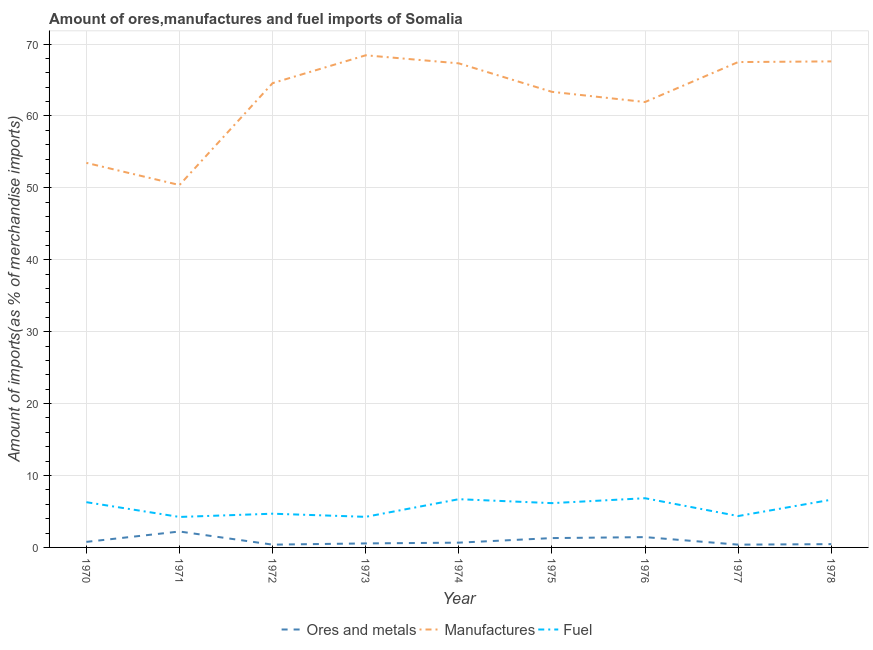How many different coloured lines are there?
Provide a short and direct response. 3. Does the line corresponding to percentage of fuel imports intersect with the line corresponding to percentage of manufactures imports?
Offer a very short reply. No. What is the percentage of fuel imports in 1977?
Provide a short and direct response. 4.36. Across all years, what is the maximum percentage of fuel imports?
Offer a terse response. 6.84. Across all years, what is the minimum percentage of ores and metals imports?
Offer a terse response. 0.39. In which year was the percentage of fuel imports maximum?
Offer a very short reply. 1976. In which year was the percentage of manufactures imports minimum?
Ensure brevity in your answer.  1971. What is the total percentage of ores and metals imports in the graph?
Your answer should be very brief. 8.17. What is the difference between the percentage of manufactures imports in 1971 and that in 1978?
Make the answer very short. -17.19. What is the difference between the percentage of fuel imports in 1971 and the percentage of ores and metals imports in 1977?
Offer a very short reply. 3.85. What is the average percentage of manufactures imports per year?
Offer a very short reply. 62.73. In the year 1978, what is the difference between the percentage of manufactures imports and percentage of ores and metals imports?
Give a very brief answer. 67.13. What is the ratio of the percentage of manufactures imports in 1974 to that in 1978?
Provide a short and direct response. 1. Is the difference between the percentage of ores and metals imports in 1971 and 1973 greater than the difference between the percentage of fuel imports in 1971 and 1973?
Provide a short and direct response. Yes. What is the difference between the highest and the second highest percentage of ores and metals imports?
Your answer should be very brief. 0.78. What is the difference between the highest and the lowest percentage of ores and metals imports?
Keep it short and to the point. 1.83. In how many years, is the percentage of fuel imports greater than the average percentage of fuel imports taken over all years?
Provide a short and direct response. 5. Does the percentage of fuel imports monotonically increase over the years?
Keep it short and to the point. No. Is the percentage of fuel imports strictly greater than the percentage of manufactures imports over the years?
Offer a terse response. No. Is the percentage of ores and metals imports strictly less than the percentage of manufactures imports over the years?
Your answer should be very brief. Yes. How many lines are there?
Ensure brevity in your answer.  3. Does the graph contain any zero values?
Your answer should be very brief. No. Does the graph contain grids?
Your answer should be very brief. Yes. How are the legend labels stacked?
Your answer should be compact. Horizontal. What is the title of the graph?
Offer a terse response. Amount of ores,manufactures and fuel imports of Somalia. What is the label or title of the X-axis?
Your answer should be very brief. Year. What is the label or title of the Y-axis?
Offer a terse response. Amount of imports(as % of merchandise imports). What is the Amount of imports(as % of merchandise imports) of Ores and metals in 1970?
Your answer should be compact. 0.77. What is the Amount of imports(as % of merchandise imports) in Manufactures in 1970?
Your answer should be very brief. 53.47. What is the Amount of imports(as % of merchandise imports) in Fuel in 1970?
Provide a succinct answer. 6.29. What is the Amount of imports(as % of merchandise imports) of Ores and metals in 1971?
Ensure brevity in your answer.  2.21. What is the Amount of imports(as % of merchandise imports) of Manufactures in 1971?
Provide a succinct answer. 50.39. What is the Amount of imports(as % of merchandise imports) of Fuel in 1971?
Provide a succinct answer. 4.24. What is the Amount of imports(as % of merchandise imports) of Ores and metals in 1972?
Give a very brief answer. 0.39. What is the Amount of imports(as % of merchandise imports) of Manufactures in 1972?
Your answer should be very brief. 64.56. What is the Amount of imports(as % of merchandise imports) in Fuel in 1972?
Give a very brief answer. 4.69. What is the Amount of imports(as % of merchandise imports) in Ores and metals in 1973?
Make the answer very short. 0.56. What is the Amount of imports(as % of merchandise imports) in Manufactures in 1973?
Offer a very short reply. 68.43. What is the Amount of imports(as % of merchandise imports) in Fuel in 1973?
Your answer should be very brief. 4.25. What is the Amount of imports(as % of merchandise imports) of Ores and metals in 1974?
Ensure brevity in your answer.  0.66. What is the Amount of imports(as % of merchandise imports) in Manufactures in 1974?
Provide a short and direct response. 67.31. What is the Amount of imports(as % of merchandise imports) of Fuel in 1974?
Your answer should be compact. 6.71. What is the Amount of imports(as % of merchandise imports) in Ores and metals in 1975?
Your response must be concise. 1.3. What is the Amount of imports(as % of merchandise imports) of Manufactures in 1975?
Make the answer very short. 63.35. What is the Amount of imports(as % of merchandise imports) of Fuel in 1975?
Provide a succinct answer. 6.16. What is the Amount of imports(as % of merchandise imports) in Ores and metals in 1976?
Provide a short and direct response. 1.43. What is the Amount of imports(as % of merchandise imports) of Manufactures in 1976?
Offer a terse response. 61.94. What is the Amount of imports(as % of merchandise imports) of Fuel in 1976?
Provide a succinct answer. 6.84. What is the Amount of imports(as % of merchandise imports) in Ores and metals in 1977?
Provide a succinct answer. 0.39. What is the Amount of imports(as % of merchandise imports) of Manufactures in 1977?
Provide a short and direct response. 67.49. What is the Amount of imports(as % of merchandise imports) in Fuel in 1977?
Offer a terse response. 4.36. What is the Amount of imports(as % of merchandise imports) of Ores and metals in 1978?
Offer a very short reply. 0.46. What is the Amount of imports(as % of merchandise imports) in Manufactures in 1978?
Provide a short and direct response. 67.59. What is the Amount of imports(as % of merchandise imports) of Fuel in 1978?
Your answer should be very brief. 6.63. Across all years, what is the maximum Amount of imports(as % of merchandise imports) in Ores and metals?
Your response must be concise. 2.21. Across all years, what is the maximum Amount of imports(as % of merchandise imports) of Manufactures?
Provide a succinct answer. 68.43. Across all years, what is the maximum Amount of imports(as % of merchandise imports) of Fuel?
Keep it short and to the point. 6.84. Across all years, what is the minimum Amount of imports(as % of merchandise imports) of Ores and metals?
Offer a very short reply. 0.39. Across all years, what is the minimum Amount of imports(as % of merchandise imports) of Manufactures?
Keep it short and to the point. 50.39. Across all years, what is the minimum Amount of imports(as % of merchandise imports) in Fuel?
Your answer should be compact. 4.24. What is the total Amount of imports(as % of merchandise imports) of Ores and metals in the graph?
Ensure brevity in your answer.  8.17. What is the total Amount of imports(as % of merchandise imports) of Manufactures in the graph?
Provide a succinct answer. 564.54. What is the total Amount of imports(as % of merchandise imports) in Fuel in the graph?
Make the answer very short. 50.18. What is the difference between the Amount of imports(as % of merchandise imports) of Ores and metals in 1970 and that in 1971?
Make the answer very short. -1.44. What is the difference between the Amount of imports(as % of merchandise imports) in Manufactures in 1970 and that in 1971?
Provide a succinct answer. 3.08. What is the difference between the Amount of imports(as % of merchandise imports) in Fuel in 1970 and that in 1971?
Offer a very short reply. 2.05. What is the difference between the Amount of imports(as % of merchandise imports) in Ores and metals in 1970 and that in 1972?
Ensure brevity in your answer.  0.39. What is the difference between the Amount of imports(as % of merchandise imports) in Manufactures in 1970 and that in 1972?
Your answer should be compact. -11.09. What is the difference between the Amount of imports(as % of merchandise imports) in Fuel in 1970 and that in 1972?
Your response must be concise. 1.6. What is the difference between the Amount of imports(as % of merchandise imports) in Ores and metals in 1970 and that in 1973?
Ensure brevity in your answer.  0.21. What is the difference between the Amount of imports(as % of merchandise imports) of Manufactures in 1970 and that in 1973?
Keep it short and to the point. -14.96. What is the difference between the Amount of imports(as % of merchandise imports) in Fuel in 1970 and that in 1973?
Your response must be concise. 2.04. What is the difference between the Amount of imports(as % of merchandise imports) of Ores and metals in 1970 and that in 1974?
Provide a short and direct response. 0.11. What is the difference between the Amount of imports(as % of merchandise imports) of Manufactures in 1970 and that in 1974?
Your response must be concise. -13.84. What is the difference between the Amount of imports(as % of merchandise imports) in Fuel in 1970 and that in 1974?
Make the answer very short. -0.42. What is the difference between the Amount of imports(as % of merchandise imports) in Ores and metals in 1970 and that in 1975?
Your response must be concise. -0.53. What is the difference between the Amount of imports(as % of merchandise imports) of Manufactures in 1970 and that in 1975?
Your answer should be compact. -9.88. What is the difference between the Amount of imports(as % of merchandise imports) in Fuel in 1970 and that in 1975?
Provide a succinct answer. 0.13. What is the difference between the Amount of imports(as % of merchandise imports) of Ores and metals in 1970 and that in 1976?
Your answer should be compact. -0.66. What is the difference between the Amount of imports(as % of merchandise imports) in Manufactures in 1970 and that in 1976?
Your answer should be very brief. -8.46. What is the difference between the Amount of imports(as % of merchandise imports) in Fuel in 1970 and that in 1976?
Your response must be concise. -0.55. What is the difference between the Amount of imports(as % of merchandise imports) of Ores and metals in 1970 and that in 1977?
Make the answer very short. 0.38. What is the difference between the Amount of imports(as % of merchandise imports) in Manufactures in 1970 and that in 1977?
Make the answer very short. -14.02. What is the difference between the Amount of imports(as % of merchandise imports) in Fuel in 1970 and that in 1977?
Give a very brief answer. 1.93. What is the difference between the Amount of imports(as % of merchandise imports) in Ores and metals in 1970 and that in 1978?
Your response must be concise. 0.31. What is the difference between the Amount of imports(as % of merchandise imports) in Manufactures in 1970 and that in 1978?
Your answer should be compact. -14.11. What is the difference between the Amount of imports(as % of merchandise imports) of Fuel in 1970 and that in 1978?
Provide a short and direct response. -0.34. What is the difference between the Amount of imports(as % of merchandise imports) of Ores and metals in 1971 and that in 1972?
Your answer should be very brief. 1.83. What is the difference between the Amount of imports(as % of merchandise imports) of Manufactures in 1971 and that in 1972?
Make the answer very short. -14.17. What is the difference between the Amount of imports(as % of merchandise imports) in Fuel in 1971 and that in 1972?
Keep it short and to the point. -0.45. What is the difference between the Amount of imports(as % of merchandise imports) of Ores and metals in 1971 and that in 1973?
Give a very brief answer. 1.66. What is the difference between the Amount of imports(as % of merchandise imports) in Manufactures in 1971 and that in 1973?
Make the answer very short. -18.04. What is the difference between the Amount of imports(as % of merchandise imports) of Fuel in 1971 and that in 1973?
Give a very brief answer. -0.02. What is the difference between the Amount of imports(as % of merchandise imports) in Ores and metals in 1971 and that in 1974?
Your response must be concise. 1.55. What is the difference between the Amount of imports(as % of merchandise imports) of Manufactures in 1971 and that in 1974?
Keep it short and to the point. -16.92. What is the difference between the Amount of imports(as % of merchandise imports) in Fuel in 1971 and that in 1974?
Make the answer very short. -2.47. What is the difference between the Amount of imports(as % of merchandise imports) of Ores and metals in 1971 and that in 1975?
Ensure brevity in your answer.  0.92. What is the difference between the Amount of imports(as % of merchandise imports) in Manufactures in 1971 and that in 1975?
Keep it short and to the point. -12.96. What is the difference between the Amount of imports(as % of merchandise imports) of Fuel in 1971 and that in 1975?
Make the answer very short. -1.92. What is the difference between the Amount of imports(as % of merchandise imports) in Ores and metals in 1971 and that in 1976?
Your answer should be very brief. 0.78. What is the difference between the Amount of imports(as % of merchandise imports) of Manufactures in 1971 and that in 1976?
Keep it short and to the point. -11.54. What is the difference between the Amount of imports(as % of merchandise imports) in Fuel in 1971 and that in 1976?
Provide a short and direct response. -2.6. What is the difference between the Amount of imports(as % of merchandise imports) of Ores and metals in 1971 and that in 1977?
Make the answer very short. 1.83. What is the difference between the Amount of imports(as % of merchandise imports) in Manufactures in 1971 and that in 1977?
Make the answer very short. -17.1. What is the difference between the Amount of imports(as % of merchandise imports) of Fuel in 1971 and that in 1977?
Give a very brief answer. -0.12. What is the difference between the Amount of imports(as % of merchandise imports) of Ores and metals in 1971 and that in 1978?
Your answer should be very brief. 1.76. What is the difference between the Amount of imports(as % of merchandise imports) in Manufactures in 1971 and that in 1978?
Offer a very short reply. -17.19. What is the difference between the Amount of imports(as % of merchandise imports) of Fuel in 1971 and that in 1978?
Give a very brief answer. -2.4. What is the difference between the Amount of imports(as % of merchandise imports) in Ores and metals in 1972 and that in 1973?
Make the answer very short. -0.17. What is the difference between the Amount of imports(as % of merchandise imports) of Manufactures in 1972 and that in 1973?
Your answer should be very brief. -3.87. What is the difference between the Amount of imports(as % of merchandise imports) in Fuel in 1972 and that in 1973?
Keep it short and to the point. 0.43. What is the difference between the Amount of imports(as % of merchandise imports) in Ores and metals in 1972 and that in 1974?
Offer a terse response. -0.28. What is the difference between the Amount of imports(as % of merchandise imports) in Manufactures in 1972 and that in 1974?
Provide a succinct answer. -2.75. What is the difference between the Amount of imports(as % of merchandise imports) in Fuel in 1972 and that in 1974?
Your answer should be very brief. -2.02. What is the difference between the Amount of imports(as % of merchandise imports) in Ores and metals in 1972 and that in 1975?
Ensure brevity in your answer.  -0.91. What is the difference between the Amount of imports(as % of merchandise imports) of Manufactures in 1972 and that in 1975?
Provide a short and direct response. 1.21. What is the difference between the Amount of imports(as % of merchandise imports) in Fuel in 1972 and that in 1975?
Your answer should be compact. -1.47. What is the difference between the Amount of imports(as % of merchandise imports) in Ores and metals in 1972 and that in 1976?
Offer a terse response. -1.05. What is the difference between the Amount of imports(as % of merchandise imports) of Manufactures in 1972 and that in 1976?
Provide a short and direct response. 2.63. What is the difference between the Amount of imports(as % of merchandise imports) of Fuel in 1972 and that in 1976?
Provide a succinct answer. -2.15. What is the difference between the Amount of imports(as % of merchandise imports) of Ores and metals in 1972 and that in 1977?
Offer a very short reply. -0. What is the difference between the Amount of imports(as % of merchandise imports) in Manufactures in 1972 and that in 1977?
Give a very brief answer. -2.93. What is the difference between the Amount of imports(as % of merchandise imports) of Fuel in 1972 and that in 1977?
Make the answer very short. 0.33. What is the difference between the Amount of imports(as % of merchandise imports) in Ores and metals in 1972 and that in 1978?
Ensure brevity in your answer.  -0.07. What is the difference between the Amount of imports(as % of merchandise imports) in Manufactures in 1972 and that in 1978?
Your answer should be compact. -3.02. What is the difference between the Amount of imports(as % of merchandise imports) in Fuel in 1972 and that in 1978?
Offer a terse response. -1.95. What is the difference between the Amount of imports(as % of merchandise imports) of Ores and metals in 1973 and that in 1974?
Give a very brief answer. -0.11. What is the difference between the Amount of imports(as % of merchandise imports) of Manufactures in 1973 and that in 1974?
Provide a succinct answer. 1.12. What is the difference between the Amount of imports(as % of merchandise imports) of Fuel in 1973 and that in 1974?
Ensure brevity in your answer.  -2.45. What is the difference between the Amount of imports(as % of merchandise imports) in Ores and metals in 1973 and that in 1975?
Provide a short and direct response. -0.74. What is the difference between the Amount of imports(as % of merchandise imports) in Manufactures in 1973 and that in 1975?
Offer a very short reply. 5.08. What is the difference between the Amount of imports(as % of merchandise imports) in Fuel in 1973 and that in 1975?
Offer a very short reply. -1.9. What is the difference between the Amount of imports(as % of merchandise imports) of Ores and metals in 1973 and that in 1976?
Ensure brevity in your answer.  -0.88. What is the difference between the Amount of imports(as % of merchandise imports) in Manufactures in 1973 and that in 1976?
Provide a short and direct response. 6.5. What is the difference between the Amount of imports(as % of merchandise imports) in Fuel in 1973 and that in 1976?
Give a very brief answer. -2.59. What is the difference between the Amount of imports(as % of merchandise imports) of Ores and metals in 1973 and that in 1977?
Offer a terse response. 0.17. What is the difference between the Amount of imports(as % of merchandise imports) of Manufactures in 1973 and that in 1977?
Offer a terse response. 0.94. What is the difference between the Amount of imports(as % of merchandise imports) of Fuel in 1973 and that in 1977?
Your response must be concise. -0.11. What is the difference between the Amount of imports(as % of merchandise imports) in Ores and metals in 1973 and that in 1978?
Make the answer very short. 0.1. What is the difference between the Amount of imports(as % of merchandise imports) in Manufactures in 1973 and that in 1978?
Keep it short and to the point. 0.85. What is the difference between the Amount of imports(as % of merchandise imports) in Fuel in 1973 and that in 1978?
Keep it short and to the point. -2.38. What is the difference between the Amount of imports(as % of merchandise imports) in Ores and metals in 1974 and that in 1975?
Your answer should be very brief. -0.64. What is the difference between the Amount of imports(as % of merchandise imports) of Manufactures in 1974 and that in 1975?
Provide a succinct answer. 3.96. What is the difference between the Amount of imports(as % of merchandise imports) of Fuel in 1974 and that in 1975?
Provide a succinct answer. 0.55. What is the difference between the Amount of imports(as % of merchandise imports) in Ores and metals in 1974 and that in 1976?
Make the answer very short. -0.77. What is the difference between the Amount of imports(as % of merchandise imports) in Manufactures in 1974 and that in 1976?
Offer a very short reply. 5.38. What is the difference between the Amount of imports(as % of merchandise imports) in Fuel in 1974 and that in 1976?
Ensure brevity in your answer.  -0.13. What is the difference between the Amount of imports(as % of merchandise imports) of Ores and metals in 1974 and that in 1977?
Keep it short and to the point. 0.28. What is the difference between the Amount of imports(as % of merchandise imports) of Manufactures in 1974 and that in 1977?
Give a very brief answer. -0.18. What is the difference between the Amount of imports(as % of merchandise imports) in Fuel in 1974 and that in 1977?
Provide a succinct answer. 2.35. What is the difference between the Amount of imports(as % of merchandise imports) of Ores and metals in 1974 and that in 1978?
Your answer should be compact. 0.21. What is the difference between the Amount of imports(as % of merchandise imports) of Manufactures in 1974 and that in 1978?
Ensure brevity in your answer.  -0.27. What is the difference between the Amount of imports(as % of merchandise imports) of Fuel in 1974 and that in 1978?
Make the answer very short. 0.07. What is the difference between the Amount of imports(as % of merchandise imports) in Ores and metals in 1975 and that in 1976?
Your response must be concise. -0.14. What is the difference between the Amount of imports(as % of merchandise imports) of Manufactures in 1975 and that in 1976?
Make the answer very short. 1.42. What is the difference between the Amount of imports(as % of merchandise imports) of Fuel in 1975 and that in 1976?
Your answer should be compact. -0.68. What is the difference between the Amount of imports(as % of merchandise imports) in Ores and metals in 1975 and that in 1977?
Provide a succinct answer. 0.91. What is the difference between the Amount of imports(as % of merchandise imports) in Manufactures in 1975 and that in 1977?
Make the answer very short. -4.14. What is the difference between the Amount of imports(as % of merchandise imports) in Fuel in 1975 and that in 1977?
Keep it short and to the point. 1.8. What is the difference between the Amount of imports(as % of merchandise imports) in Ores and metals in 1975 and that in 1978?
Offer a very short reply. 0.84. What is the difference between the Amount of imports(as % of merchandise imports) of Manufactures in 1975 and that in 1978?
Provide a short and direct response. -4.23. What is the difference between the Amount of imports(as % of merchandise imports) in Fuel in 1975 and that in 1978?
Give a very brief answer. -0.48. What is the difference between the Amount of imports(as % of merchandise imports) of Ores and metals in 1976 and that in 1977?
Offer a very short reply. 1.05. What is the difference between the Amount of imports(as % of merchandise imports) of Manufactures in 1976 and that in 1977?
Give a very brief answer. -5.56. What is the difference between the Amount of imports(as % of merchandise imports) of Fuel in 1976 and that in 1977?
Your answer should be compact. 2.48. What is the difference between the Amount of imports(as % of merchandise imports) of Ores and metals in 1976 and that in 1978?
Your answer should be compact. 0.98. What is the difference between the Amount of imports(as % of merchandise imports) of Manufactures in 1976 and that in 1978?
Provide a succinct answer. -5.65. What is the difference between the Amount of imports(as % of merchandise imports) of Fuel in 1976 and that in 1978?
Provide a succinct answer. 0.21. What is the difference between the Amount of imports(as % of merchandise imports) of Ores and metals in 1977 and that in 1978?
Offer a terse response. -0.07. What is the difference between the Amount of imports(as % of merchandise imports) of Manufactures in 1977 and that in 1978?
Give a very brief answer. -0.09. What is the difference between the Amount of imports(as % of merchandise imports) in Fuel in 1977 and that in 1978?
Provide a short and direct response. -2.27. What is the difference between the Amount of imports(as % of merchandise imports) in Ores and metals in 1970 and the Amount of imports(as % of merchandise imports) in Manufactures in 1971?
Provide a short and direct response. -49.62. What is the difference between the Amount of imports(as % of merchandise imports) in Ores and metals in 1970 and the Amount of imports(as % of merchandise imports) in Fuel in 1971?
Provide a succinct answer. -3.47. What is the difference between the Amount of imports(as % of merchandise imports) of Manufactures in 1970 and the Amount of imports(as % of merchandise imports) of Fuel in 1971?
Provide a succinct answer. 49.24. What is the difference between the Amount of imports(as % of merchandise imports) of Ores and metals in 1970 and the Amount of imports(as % of merchandise imports) of Manufactures in 1972?
Ensure brevity in your answer.  -63.79. What is the difference between the Amount of imports(as % of merchandise imports) of Ores and metals in 1970 and the Amount of imports(as % of merchandise imports) of Fuel in 1972?
Provide a succinct answer. -3.92. What is the difference between the Amount of imports(as % of merchandise imports) of Manufactures in 1970 and the Amount of imports(as % of merchandise imports) of Fuel in 1972?
Give a very brief answer. 48.79. What is the difference between the Amount of imports(as % of merchandise imports) in Ores and metals in 1970 and the Amount of imports(as % of merchandise imports) in Manufactures in 1973?
Offer a very short reply. -67.66. What is the difference between the Amount of imports(as % of merchandise imports) in Ores and metals in 1970 and the Amount of imports(as % of merchandise imports) in Fuel in 1973?
Your response must be concise. -3.48. What is the difference between the Amount of imports(as % of merchandise imports) in Manufactures in 1970 and the Amount of imports(as % of merchandise imports) in Fuel in 1973?
Provide a succinct answer. 49.22. What is the difference between the Amount of imports(as % of merchandise imports) of Ores and metals in 1970 and the Amount of imports(as % of merchandise imports) of Manufactures in 1974?
Your answer should be very brief. -66.54. What is the difference between the Amount of imports(as % of merchandise imports) in Ores and metals in 1970 and the Amount of imports(as % of merchandise imports) in Fuel in 1974?
Provide a short and direct response. -5.94. What is the difference between the Amount of imports(as % of merchandise imports) of Manufactures in 1970 and the Amount of imports(as % of merchandise imports) of Fuel in 1974?
Offer a very short reply. 46.77. What is the difference between the Amount of imports(as % of merchandise imports) of Ores and metals in 1970 and the Amount of imports(as % of merchandise imports) of Manufactures in 1975?
Keep it short and to the point. -62.58. What is the difference between the Amount of imports(as % of merchandise imports) of Ores and metals in 1970 and the Amount of imports(as % of merchandise imports) of Fuel in 1975?
Offer a terse response. -5.39. What is the difference between the Amount of imports(as % of merchandise imports) in Manufactures in 1970 and the Amount of imports(as % of merchandise imports) in Fuel in 1975?
Your response must be concise. 47.32. What is the difference between the Amount of imports(as % of merchandise imports) in Ores and metals in 1970 and the Amount of imports(as % of merchandise imports) in Manufactures in 1976?
Give a very brief answer. -61.16. What is the difference between the Amount of imports(as % of merchandise imports) in Ores and metals in 1970 and the Amount of imports(as % of merchandise imports) in Fuel in 1976?
Your answer should be compact. -6.07. What is the difference between the Amount of imports(as % of merchandise imports) in Manufactures in 1970 and the Amount of imports(as % of merchandise imports) in Fuel in 1976?
Your answer should be compact. 46.63. What is the difference between the Amount of imports(as % of merchandise imports) in Ores and metals in 1970 and the Amount of imports(as % of merchandise imports) in Manufactures in 1977?
Offer a very short reply. -66.72. What is the difference between the Amount of imports(as % of merchandise imports) in Ores and metals in 1970 and the Amount of imports(as % of merchandise imports) in Fuel in 1977?
Offer a very short reply. -3.59. What is the difference between the Amount of imports(as % of merchandise imports) of Manufactures in 1970 and the Amount of imports(as % of merchandise imports) of Fuel in 1977?
Provide a short and direct response. 49.11. What is the difference between the Amount of imports(as % of merchandise imports) in Ores and metals in 1970 and the Amount of imports(as % of merchandise imports) in Manufactures in 1978?
Provide a succinct answer. -66.81. What is the difference between the Amount of imports(as % of merchandise imports) in Ores and metals in 1970 and the Amount of imports(as % of merchandise imports) in Fuel in 1978?
Ensure brevity in your answer.  -5.86. What is the difference between the Amount of imports(as % of merchandise imports) in Manufactures in 1970 and the Amount of imports(as % of merchandise imports) in Fuel in 1978?
Make the answer very short. 46.84. What is the difference between the Amount of imports(as % of merchandise imports) of Ores and metals in 1971 and the Amount of imports(as % of merchandise imports) of Manufactures in 1972?
Your answer should be very brief. -62.35. What is the difference between the Amount of imports(as % of merchandise imports) of Ores and metals in 1971 and the Amount of imports(as % of merchandise imports) of Fuel in 1972?
Provide a short and direct response. -2.48. What is the difference between the Amount of imports(as % of merchandise imports) in Manufactures in 1971 and the Amount of imports(as % of merchandise imports) in Fuel in 1972?
Your response must be concise. 45.7. What is the difference between the Amount of imports(as % of merchandise imports) in Ores and metals in 1971 and the Amount of imports(as % of merchandise imports) in Manufactures in 1973?
Keep it short and to the point. -66.22. What is the difference between the Amount of imports(as % of merchandise imports) in Ores and metals in 1971 and the Amount of imports(as % of merchandise imports) in Fuel in 1973?
Your response must be concise. -2.04. What is the difference between the Amount of imports(as % of merchandise imports) of Manufactures in 1971 and the Amount of imports(as % of merchandise imports) of Fuel in 1973?
Your answer should be compact. 46.14. What is the difference between the Amount of imports(as % of merchandise imports) of Ores and metals in 1971 and the Amount of imports(as % of merchandise imports) of Manufactures in 1974?
Provide a short and direct response. -65.1. What is the difference between the Amount of imports(as % of merchandise imports) in Ores and metals in 1971 and the Amount of imports(as % of merchandise imports) in Fuel in 1974?
Make the answer very short. -4.49. What is the difference between the Amount of imports(as % of merchandise imports) of Manufactures in 1971 and the Amount of imports(as % of merchandise imports) of Fuel in 1974?
Your response must be concise. 43.68. What is the difference between the Amount of imports(as % of merchandise imports) of Ores and metals in 1971 and the Amount of imports(as % of merchandise imports) of Manufactures in 1975?
Provide a succinct answer. -61.14. What is the difference between the Amount of imports(as % of merchandise imports) of Ores and metals in 1971 and the Amount of imports(as % of merchandise imports) of Fuel in 1975?
Your answer should be very brief. -3.94. What is the difference between the Amount of imports(as % of merchandise imports) of Manufactures in 1971 and the Amount of imports(as % of merchandise imports) of Fuel in 1975?
Keep it short and to the point. 44.23. What is the difference between the Amount of imports(as % of merchandise imports) of Ores and metals in 1971 and the Amount of imports(as % of merchandise imports) of Manufactures in 1976?
Provide a short and direct response. -59.72. What is the difference between the Amount of imports(as % of merchandise imports) of Ores and metals in 1971 and the Amount of imports(as % of merchandise imports) of Fuel in 1976?
Your response must be concise. -4.63. What is the difference between the Amount of imports(as % of merchandise imports) in Manufactures in 1971 and the Amount of imports(as % of merchandise imports) in Fuel in 1976?
Provide a succinct answer. 43.55. What is the difference between the Amount of imports(as % of merchandise imports) in Ores and metals in 1971 and the Amount of imports(as % of merchandise imports) in Manufactures in 1977?
Provide a short and direct response. -65.28. What is the difference between the Amount of imports(as % of merchandise imports) in Ores and metals in 1971 and the Amount of imports(as % of merchandise imports) in Fuel in 1977?
Provide a short and direct response. -2.15. What is the difference between the Amount of imports(as % of merchandise imports) of Manufactures in 1971 and the Amount of imports(as % of merchandise imports) of Fuel in 1977?
Your answer should be very brief. 46.03. What is the difference between the Amount of imports(as % of merchandise imports) of Ores and metals in 1971 and the Amount of imports(as % of merchandise imports) of Manufactures in 1978?
Your answer should be compact. -65.37. What is the difference between the Amount of imports(as % of merchandise imports) of Ores and metals in 1971 and the Amount of imports(as % of merchandise imports) of Fuel in 1978?
Make the answer very short. -4.42. What is the difference between the Amount of imports(as % of merchandise imports) in Manufactures in 1971 and the Amount of imports(as % of merchandise imports) in Fuel in 1978?
Provide a short and direct response. 43.76. What is the difference between the Amount of imports(as % of merchandise imports) in Ores and metals in 1972 and the Amount of imports(as % of merchandise imports) in Manufactures in 1973?
Ensure brevity in your answer.  -68.05. What is the difference between the Amount of imports(as % of merchandise imports) in Ores and metals in 1972 and the Amount of imports(as % of merchandise imports) in Fuel in 1973?
Give a very brief answer. -3.87. What is the difference between the Amount of imports(as % of merchandise imports) in Manufactures in 1972 and the Amount of imports(as % of merchandise imports) in Fuel in 1973?
Your response must be concise. 60.31. What is the difference between the Amount of imports(as % of merchandise imports) in Ores and metals in 1972 and the Amount of imports(as % of merchandise imports) in Manufactures in 1974?
Provide a short and direct response. -66.93. What is the difference between the Amount of imports(as % of merchandise imports) of Ores and metals in 1972 and the Amount of imports(as % of merchandise imports) of Fuel in 1974?
Provide a short and direct response. -6.32. What is the difference between the Amount of imports(as % of merchandise imports) in Manufactures in 1972 and the Amount of imports(as % of merchandise imports) in Fuel in 1974?
Make the answer very short. 57.85. What is the difference between the Amount of imports(as % of merchandise imports) in Ores and metals in 1972 and the Amount of imports(as % of merchandise imports) in Manufactures in 1975?
Provide a succinct answer. -62.97. What is the difference between the Amount of imports(as % of merchandise imports) in Ores and metals in 1972 and the Amount of imports(as % of merchandise imports) in Fuel in 1975?
Your answer should be compact. -5.77. What is the difference between the Amount of imports(as % of merchandise imports) of Manufactures in 1972 and the Amount of imports(as % of merchandise imports) of Fuel in 1975?
Your response must be concise. 58.4. What is the difference between the Amount of imports(as % of merchandise imports) of Ores and metals in 1972 and the Amount of imports(as % of merchandise imports) of Manufactures in 1976?
Your answer should be very brief. -61.55. What is the difference between the Amount of imports(as % of merchandise imports) in Ores and metals in 1972 and the Amount of imports(as % of merchandise imports) in Fuel in 1976?
Keep it short and to the point. -6.45. What is the difference between the Amount of imports(as % of merchandise imports) of Manufactures in 1972 and the Amount of imports(as % of merchandise imports) of Fuel in 1976?
Provide a short and direct response. 57.72. What is the difference between the Amount of imports(as % of merchandise imports) in Ores and metals in 1972 and the Amount of imports(as % of merchandise imports) in Manufactures in 1977?
Give a very brief answer. -67.11. What is the difference between the Amount of imports(as % of merchandise imports) of Ores and metals in 1972 and the Amount of imports(as % of merchandise imports) of Fuel in 1977?
Keep it short and to the point. -3.98. What is the difference between the Amount of imports(as % of merchandise imports) in Manufactures in 1972 and the Amount of imports(as % of merchandise imports) in Fuel in 1977?
Make the answer very short. 60.2. What is the difference between the Amount of imports(as % of merchandise imports) of Ores and metals in 1972 and the Amount of imports(as % of merchandise imports) of Manufactures in 1978?
Your answer should be compact. -67.2. What is the difference between the Amount of imports(as % of merchandise imports) in Ores and metals in 1972 and the Amount of imports(as % of merchandise imports) in Fuel in 1978?
Offer a terse response. -6.25. What is the difference between the Amount of imports(as % of merchandise imports) in Manufactures in 1972 and the Amount of imports(as % of merchandise imports) in Fuel in 1978?
Ensure brevity in your answer.  57.93. What is the difference between the Amount of imports(as % of merchandise imports) of Ores and metals in 1973 and the Amount of imports(as % of merchandise imports) of Manufactures in 1974?
Ensure brevity in your answer.  -66.75. What is the difference between the Amount of imports(as % of merchandise imports) of Ores and metals in 1973 and the Amount of imports(as % of merchandise imports) of Fuel in 1974?
Give a very brief answer. -6.15. What is the difference between the Amount of imports(as % of merchandise imports) of Manufactures in 1973 and the Amount of imports(as % of merchandise imports) of Fuel in 1974?
Your response must be concise. 61.73. What is the difference between the Amount of imports(as % of merchandise imports) of Ores and metals in 1973 and the Amount of imports(as % of merchandise imports) of Manufactures in 1975?
Offer a very short reply. -62.79. What is the difference between the Amount of imports(as % of merchandise imports) of Ores and metals in 1973 and the Amount of imports(as % of merchandise imports) of Fuel in 1975?
Your response must be concise. -5.6. What is the difference between the Amount of imports(as % of merchandise imports) of Manufactures in 1973 and the Amount of imports(as % of merchandise imports) of Fuel in 1975?
Give a very brief answer. 62.28. What is the difference between the Amount of imports(as % of merchandise imports) of Ores and metals in 1973 and the Amount of imports(as % of merchandise imports) of Manufactures in 1976?
Your answer should be very brief. -61.38. What is the difference between the Amount of imports(as % of merchandise imports) in Ores and metals in 1973 and the Amount of imports(as % of merchandise imports) in Fuel in 1976?
Provide a short and direct response. -6.28. What is the difference between the Amount of imports(as % of merchandise imports) in Manufactures in 1973 and the Amount of imports(as % of merchandise imports) in Fuel in 1976?
Ensure brevity in your answer.  61.59. What is the difference between the Amount of imports(as % of merchandise imports) in Ores and metals in 1973 and the Amount of imports(as % of merchandise imports) in Manufactures in 1977?
Make the answer very short. -66.93. What is the difference between the Amount of imports(as % of merchandise imports) of Ores and metals in 1973 and the Amount of imports(as % of merchandise imports) of Fuel in 1977?
Offer a terse response. -3.8. What is the difference between the Amount of imports(as % of merchandise imports) of Manufactures in 1973 and the Amount of imports(as % of merchandise imports) of Fuel in 1977?
Give a very brief answer. 64.07. What is the difference between the Amount of imports(as % of merchandise imports) in Ores and metals in 1973 and the Amount of imports(as % of merchandise imports) in Manufactures in 1978?
Ensure brevity in your answer.  -67.03. What is the difference between the Amount of imports(as % of merchandise imports) of Ores and metals in 1973 and the Amount of imports(as % of merchandise imports) of Fuel in 1978?
Give a very brief answer. -6.08. What is the difference between the Amount of imports(as % of merchandise imports) in Manufactures in 1973 and the Amount of imports(as % of merchandise imports) in Fuel in 1978?
Provide a succinct answer. 61.8. What is the difference between the Amount of imports(as % of merchandise imports) of Ores and metals in 1974 and the Amount of imports(as % of merchandise imports) of Manufactures in 1975?
Offer a very short reply. -62.69. What is the difference between the Amount of imports(as % of merchandise imports) in Ores and metals in 1974 and the Amount of imports(as % of merchandise imports) in Fuel in 1975?
Your response must be concise. -5.5. What is the difference between the Amount of imports(as % of merchandise imports) of Manufactures in 1974 and the Amount of imports(as % of merchandise imports) of Fuel in 1975?
Your answer should be very brief. 61.15. What is the difference between the Amount of imports(as % of merchandise imports) in Ores and metals in 1974 and the Amount of imports(as % of merchandise imports) in Manufactures in 1976?
Offer a terse response. -61.27. What is the difference between the Amount of imports(as % of merchandise imports) of Ores and metals in 1974 and the Amount of imports(as % of merchandise imports) of Fuel in 1976?
Ensure brevity in your answer.  -6.18. What is the difference between the Amount of imports(as % of merchandise imports) in Manufactures in 1974 and the Amount of imports(as % of merchandise imports) in Fuel in 1976?
Ensure brevity in your answer.  60.47. What is the difference between the Amount of imports(as % of merchandise imports) in Ores and metals in 1974 and the Amount of imports(as % of merchandise imports) in Manufactures in 1977?
Provide a short and direct response. -66.83. What is the difference between the Amount of imports(as % of merchandise imports) of Ores and metals in 1974 and the Amount of imports(as % of merchandise imports) of Fuel in 1977?
Offer a very short reply. -3.7. What is the difference between the Amount of imports(as % of merchandise imports) of Manufactures in 1974 and the Amount of imports(as % of merchandise imports) of Fuel in 1977?
Ensure brevity in your answer.  62.95. What is the difference between the Amount of imports(as % of merchandise imports) of Ores and metals in 1974 and the Amount of imports(as % of merchandise imports) of Manufactures in 1978?
Your response must be concise. -66.92. What is the difference between the Amount of imports(as % of merchandise imports) in Ores and metals in 1974 and the Amount of imports(as % of merchandise imports) in Fuel in 1978?
Provide a succinct answer. -5.97. What is the difference between the Amount of imports(as % of merchandise imports) of Manufactures in 1974 and the Amount of imports(as % of merchandise imports) of Fuel in 1978?
Your response must be concise. 60.68. What is the difference between the Amount of imports(as % of merchandise imports) in Ores and metals in 1975 and the Amount of imports(as % of merchandise imports) in Manufactures in 1976?
Offer a very short reply. -60.64. What is the difference between the Amount of imports(as % of merchandise imports) in Ores and metals in 1975 and the Amount of imports(as % of merchandise imports) in Fuel in 1976?
Keep it short and to the point. -5.54. What is the difference between the Amount of imports(as % of merchandise imports) of Manufactures in 1975 and the Amount of imports(as % of merchandise imports) of Fuel in 1976?
Your response must be concise. 56.51. What is the difference between the Amount of imports(as % of merchandise imports) of Ores and metals in 1975 and the Amount of imports(as % of merchandise imports) of Manufactures in 1977?
Give a very brief answer. -66.19. What is the difference between the Amount of imports(as % of merchandise imports) of Ores and metals in 1975 and the Amount of imports(as % of merchandise imports) of Fuel in 1977?
Offer a terse response. -3.06. What is the difference between the Amount of imports(as % of merchandise imports) of Manufactures in 1975 and the Amount of imports(as % of merchandise imports) of Fuel in 1977?
Offer a terse response. 58.99. What is the difference between the Amount of imports(as % of merchandise imports) of Ores and metals in 1975 and the Amount of imports(as % of merchandise imports) of Manufactures in 1978?
Make the answer very short. -66.29. What is the difference between the Amount of imports(as % of merchandise imports) in Ores and metals in 1975 and the Amount of imports(as % of merchandise imports) in Fuel in 1978?
Give a very brief answer. -5.34. What is the difference between the Amount of imports(as % of merchandise imports) in Manufactures in 1975 and the Amount of imports(as % of merchandise imports) in Fuel in 1978?
Offer a terse response. 56.72. What is the difference between the Amount of imports(as % of merchandise imports) of Ores and metals in 1976 and the Amount of imports(as % of merchandise imports) of Manufactures in 1977?
Offer a terse response. -66.06. What is the difference between the Amount of imports(as % of merchandise imports) in Ores and metals in 1976 and the Amount of imports(as % of merchandise imports) in Fuel in 1977?
Provide a short and direct response. -2.93. What is the difference between the Amount of imports(as % of merchandise imports) in Manufactures in 1976 and the Amount of imports(as % of merchandise imports) in Fuel in 1977?
Make the answer very short. 57.57. What is the difference between the Amount of imports(as % of merchandise imports) in Ores and metals in 1976 and the Amount of imports(as % of merchandise imports) in Manufactures in 1978?
Make the answer very short. -66.15. What is the difference between the Amount of imports(as % of merchandise imports) in Ores and metals in 1976 and the Amount of imports(as % of merchandise imports) in Fuel in 1978?
Provide a succinct answer. -5.2. What is the difference between the Amount of imports(as % of merchandise imports) in Manufactures in 1976 and the Amount of imports(as % of merchandise imports) in Fuel in 1978?
Offer a terse response. 55.3. What is the difference between the Amount of imports(as % of merchandise imports) in Ores and metals in 1977 and the Amount of imports(as % of merchandise imports) in Manufactures in 1978?
Offer a very short reply. -67.2. What is the difference between the Amount of imports(as % of merchandise imports) in Ores and metals in 1977 and the Amount of imports(as % of merchandise imports) in Fuel in 1978?
Provide a short and direct response. -6.25. What is the difference between the Amount of imports(as % of merchandise imports) in Manufactures in 1977 and the Amount of imports(as % of merchandise imports) in Fuel in 1978?
Ensure brevity in your answer.  60.86. What is the average Amount of imports(as % of merchandise imports) of Ores and metals per year?
Give a very brief answer. 0.91. What is the average Amount of imports(as % of merchandise imports) of Manufactures per year?
Your answer should be very brief. 62.73. What is the average Amount of imports(as % of merchandise imports) in Fuel per year?
Your response must be concise. 5.58. In the year 1970, what is the difference between the Amount of imports(as % of merchandise imports) of Ores and metals and Amount of imports(as % of merchandise imports) of Manufactures?
Offer a terse response. -52.7. In the year 1970, what is the difference between the Amount of imports(as % of merchandise imports) of Ores and metals and Amount of imports(as % of merchandise imports) of Fuel?
Provide a succinct answer. -5.52. In the year 1970, what is the difference between the Amount of imports(as % of merchandise imports) of Manufactures and Amount of imports(as % of merchandise imports) of Fuel?
Offer a terse response. 47.18. In the year 1971, what is the difference between the Amount of imports(as % of merchandise imports) in Ores and metals and Amount of imports(as % of merchandise imports) in Manufactures?
Offer a terse response. -48.18. In the year 1971, what is the difference between the Amount of imports(as % of merchandise imports) in Ores and metals and Amount of imports(as % of merchandise imports) in Fuel?
Provide a short and direct response. -2.02. In the year 1971, what is the difference between the Amount of imports(as % of merchandise imports) in Manufactures and Amount of imports(as % of merchandise imports) in Fuel?
Your answer should be very brief. 46.15. In the year 1972, what is the difference between the Amount of imports(as % of merchandise imports) in Ores and metals and Amount of imports(as % of merchandise imports) in Manufactures?
Keep it short and to the point. -64.18. In the year 1972, what is the difference between the Amount of imports(as % of merchandise imports) of Ores and metals and Amount of imports(as % of merchandise imports) of Fuel?
Make the answer very short. -4.3. In the year 1972, what is the difference between the Amount of imports(as % of merchandise imports) of Manufactures and Amount of imports(as % of merchandise imports) of Fuel?
Make the answer very short. 59.87. In the year 1973, what is the difference between the Amount of imports(as % of merchandise imports) of Ores and metals and Amount of imports(as % of merchandise imports) of Manufactures?
Your response must be concise. -67.88. In the year 1973, what is the difference between the Amount of imports(as % of merchandise imports) in Ores and metals and Amount of imports(as % of merchandise imports) in Fuel?
Your answer should be compact. -3.7. In the year 1973, what is the difference between the Amount of imports(as % of merchandise imports) of Manufactures and Amount of imports(as % of merchandise imports) of Fuel?
Provide a short and direct response. 64.18. In the year 1974, what is the difference between the Amount of imports(as % of merchandise imports) of Ores and metals and Amount of imports(as % of merchandise imports) of Manufactures?
Your answer should be very brief. -66.65. In the year 1974, what is the difference between the Amount of imports(as % of merchandise imports) in Ores and metals and Amount of imports(as % of merchandise imports) in Fuel?
Give a very brief answer. -6.04. In the year 1974, what is the difference between the Amount of imports(as % of merchandise imports) in Manufactures and Amount of imports(as % of merchandise imports) in Fuel?
Provide a short and direct response. 60.6. In the year 1975, what is the difference between the Amount of imports(as % of merchandise imports) in Ores and metals and Amount of imports(as % of merchandise imports) in Manufactures?
Offer a terse response. -62.05. In the year 1975, what is the difference between the Amount of imports(as % of merchandise imports) of Ores and metals and Amount of imports(as % of merchandise imports) of Fuel?
Your response must be concise. -4.86. In the year 1975, what is the difference between the Amount of imports(as % of merchandise imports) of Manufactures and Amount of imports(as % of merchandise imports) of Fuel?
Offer a terse response. 57.19. In the year 1976, what is the difference between the Amount of imports(as % of merchandise imports) of Ores and metals and Amount of imports(as % of merchandise imports) of Manufactures?
Offer a very short reply. -60.5. In the year 1976, what is the difference between the Amount of imports(as % of merchandise imports) in Ores and metals and Amount of imports(as % of merchandise imports) in Fuel?
Offer a very short reply. -5.41. In the year 1976, what is the difference between the Amount of imports(as % of merchandise imports) in Manufactures and Amount of imports(as % of merchandise imports) in Fuel?
Your response must be concise. 55.1. In the year 1977, what is the difference between the Amount of imports(as % of merchandise imports) in Ores and metals and Amount of imports(as % of merchandise imports) in Manufactures?
Give a very brief answer. -67.11. In the year 1977, what is the difference between the Amount of imports(as % of merchandise imports) in Ores and metals and Amount of imports(as % of merchandise imports) in Fuel?
Give a very brief answer. -3.98. In the year 1977, what is the difference between the Amount of imports(as % of merchandise imports) in Manufactures and Amount of imports(as % of merchandise imports) in Fuel?
Make the answer very short. 63.13. In the year 1978, what is the difference between the Amount of imports(as % of merchandise imports) of Ores and metals and Amount of imports(as % of merchandise imports) of Manufactures?
Your answer should be compact. -67.13. In the year 1978, what is the difference between the Amount of imports(as % of merchandise imports) of Ores and metals and Amount of imports(as % of merchandise imports) of Fuel?
Your response must be concise. -6.18. In the year 1978, what is the difference between the Amount of imports(as % of merchandise imports) in Manufactures and Amount of imports(as % of merchandise imports) in Fuel?
Your response must be concise. 60.95. What is the ratio of the Amount of imports(as % of merchandise imports) of Ores and metals in 1970 to that in 1971?
Offer a very short reply. 0.35. What is the ratio of the Amount of imports(as % of merchandise imports) of Manufactures in 1970 to that in 1971?
Make the answer very short. 1.06. What is the ratio of the Amount of imports(as % of merchandise imports) of Fuel in 1970 to that in 1971?
Offer a terse response. 1.48. What is the ratio of the Amount of imports(as % of merchandise imports) in Ores and metals in 1970 to that in 1972?
Your answer should be very brief. 2. What is the ratio of the Amount of imports(as % of merchandise imports) in Manufactures in 1970 to that in 1972?
Give a very brief answer. 0.83. What is the ratio of the Amount of imports(as % of merchandise imports) in Fuel in 1970 to that in 1972?
Give a very brief answer. 1.34. What is the ratio of the Amount of imports(as % of merchandise imports) of Ores and metals in 1970 to that in 1973?
Your answer should be very brief. 1.38. What is the ratio of the Amount of imports(as % of merchandise imports) of Manufactures in 1970 to that in 1973?
Provide a short and direct response. 0.78. What is the ratio of the Amount of imports(as % of merchandise imports) in Fuel in 1970 to that in 1973?
Give a very brief answer. 1.48. What is the ratio of the Amount of imports(as % of merchandise imports) of Ores and metals in 1970 to that in 1974?
Provide a short and direct response. 1.16. What is the ratio of the Amount of imports(as % of merchandise imports) of Manufactures in 1970 to that in 1974?
Offer a terse response. 0.79. What is the ratio of the Amount of imports(as % of merchandise imports) in Fuel in 1970 to that in 1974?
Your response must be concise. 0.94. What is the ratio of the Amount of imports(as % of merchandise imports) in Ores and metals in 1970 to that in 1975?
Your answer should be compact. 0.59. What is the ratio of the Amount of imports(as % of merchandise imports) in Manufactures in 1970 to that in 1975?
Make the answer very short. 0.84. What is the ratio of the Amount of imports(as % of merchandise imports) of Fuel in 1970 to that in 1975?
Your answer should be very brief. 1.02. What is the ratio of the Amount of imports(as % of merchandise imports) in Ores and metals in 1970 to that in 1976?
Offer a very short reply. 0.54. What is the ratio of the Amount of imports(as % of merchandise imports) of Manufactures in 1970 to that in 1976?
Ensure brevity in your answer.  0.86. What is the ratio of the Amount of imports(as % of merchandise imports) in Fuel in 1970 to that in 1976?
Keep it short and to the point. 0.92. What is the ratio of the Amount of imports(as % of merchandise imports) in Ores and metals in 1970 to that in 1977?
Provide a short and direct response. 1.99. What is the ratio of the Amount of imports(as % of merchandise imports) in Manufactures in 1970 to that in 1977?
Your answer should be very brief. 0.79. What is the ratio of the Amount of imports(as % of merchandise imports) of Fuel in 1970 to that in 1977?
Provide a succinct answer. 1.44. What is the ratio of the Amount of imports(as % of merchandise imports) of Ores and metals in 1970 to that in 1978?
Offer a very short reply. 1.68. What is the ratio of the Amount of imports(as % of merchandise imports) of Manufactures in 1970 to that in 1978?
Make the answer very short. 0.79. What is the ratio of the Amount of imports(as % of merchandise imports) of Fuel in 1970 to that in 1978?
Give a very brief answer. 0.95. What is the ratio of the Amount of imports(as % of merchandise imports) of Ores and metals in 1971 to that in 1972?
Make the answer very short. 5.72. What is the ratio of the Amount of imports(as % of merchandise imports) in Manufactures in 1971 to that in 1972?
Your answer should be very brief. 0.78. What is the ratio of the Amount of imports(as % of merchandise imports) in Fuel in 1971 to that in 1972?
Ensure brevity in your answer.  0.9. What is the ratio of the Amount of imports(as % of merchandise imports) in Ores and metals in 1971 to that in 1973?
Keep it short and to the point. 3.97. What is the ratio of the Amount of imports(as % of merchandise imports) in Manufactures in 1971 to that in 1973?
Provide a succinct answer. 0.74. What is the ratio of the Amount of imports(as % of merchandise imports) of Ores and metals in 1971 to that in 1974?
Provide a succinct answer. 3.34. What is the ratio of the Amount of imports(as % of merchandise imports) in Manufactures in 1971 to that in 1974?
Offer a terse response. 0.75. What is the ratio of the Amount of imports(as % of merchandise imports) of Fuel in 1971 to that in 1974?
Offer a terse response. 0.63. What is the ratio of the Amount of imports(as % of merchandise imports) of Ores and metals in 1971 to that in 1975?
Offer a terse response. 1.7. What is the ratio of the Amount of imports(as % of merchandise imports) of Manufactures in 1971 to that in 1975?
Provide a succinct answer. 0.8. What is the ratio of the Amount of imports(as % of merchandise imports) in Fuel in 1971 to that in 1975?
Ensure brevity in your answer.  0.69. What is the ratio of the Amount of imports(as % of merchandise imports) of Ores and metals in 1971 to that in 1976?
Your answer should be very brief. 1.54. What is the ratio of the Amount of imports(as % of merchandise imports) in Manufactures in 1971 to that in 1976?
Your answer should be very brief. 0.81. What is the ratio of the Amount of imports(as % of merchandise imports) of Fuel in 1971 to that in 1976?
Offer a very short reply. 0.62. What is the ratio of the Amount of imports(as % of merchandise imports) of Ores and metals in 1971 to that in 1977?
Your answer should be very brief. 5.72. What is the ratio of the Amount of imports(as % of merchandise imports) of Manufactures in 1971 to that in 1977?
Ensure brevity in your answer.  0.75. What is the ratio of the Amount of imports(as % of merchandise imports) of Fuel in 1971 to that in 1977?
Offer a very short reply. 0.97. What is the ratio of the Amount of imports(as % of merchandise imports) in Ores and metals in 1971 to that in 1978?
Your answer should be very brief. 4.83. What is the ratio of the Amount of imports(as % of merchandise imports) of Manufactures in 1971 to that in 1978?
Give a very brief answer. 0.75. What is the ratio of the Amount of imports(as % of merchandise imports) of Fuel in 1971 to that in 1978?
Make the answer very short. 0.64. What is the ratio of the Amount of imports(as % of merchandise imports) in Ores and metals in 1972 to that in 1973?
Provide a short and direct response. 0.69. What is the ratio of the Amount of imports(as % of merchandise imports) of Manufactures in 1972 to that in 1973?
Offer a terse response. 0.94. What is the ratio of the Amount of imports(as % of merchandise imports) of Fuel in 1972 to that in 1973?
Your answer should be compact. 1.1. What is the ratio of the Amount of imports(as % of merchandise imports) of Ores and metals in 1972 to that in 1974?
Your answer should be compact. 0.58. What is the ratio of the Amount of imports(as % of merchandise imports) in Manufactures in 1972 to that in 1974?
Ensure brevity in your answer.  0.96. What is the ratio of the Amount of imports(as % of merchandise imports) in Fuel in 1972 to that in 1974?
Your response must be concise. 0.7. What is the ratio of the Amount of imports(as % of merchandise imports) in Ores and metals in 1972 to that in 1975?
Ensure brevity in your answer.  0.3. What is the ratio of the Amount of imports(as % of merchandise imports) of Manufactures in 1972 to that in 1975?
Your answer should be compact. 1.02. What is the ratio of the Amount of imports(as % of merchandise imports) of Fuel in 1972 to that in 1975?
Your response must be concise. 0.76. What is the ratio of the Amount of imports(as % of merchandise imports) in Ores and metals in 1972 to that in 1976?
Give a very brief answer. 0.27. What is the ratio of the Amount of imports(as % of merchandise imports) of Manufactures in 1972 to that in 1976?
Your response must be concise. 1.04. What is the ratio of the Amount of imports(as % of merchandise imports) of Fuel in 1972 to that in 1976?
Make the answer very short. 0.69. What is the ratio of the Amount of imports(as % of merchandise imports) of Manufactures in 1972 to that in 1977?
Give a very brief answer. 0.96. What is the ratio of the Amount of imports(as % of merchandise imports) of Fuel in 1972 to that in 1977?
Keep it short and to the point. 1.07. What is the ratio of the Amount of imports(as % of merchandise imports) of Ores and metals in 1972 to that in 1978?
Your response must be concise. 0.84. What is the ratio of the Amount of imports(as % of merchandise imports) of Manufactures in 1972 to that in 1978?
Ensure brevity in your answer.  0.96. What is the ratio of the Amount of imports(as % of merchandise imports) of Fuel in 1972 to that in 1978?
Give a very brief answer. 0.71. What is the ratio of the Amount of imports(as % of merchandise imports) of Ores and metals in 1973 to that in 1974?
Offer a very short reply. 0.84. What is the ratio of the Amount of imports(as % of merchandise imports) of Manufactures in 1973 to that in 1974?
Provide a succinct answer. 1.02. What is the ratio of the Amount of imports(as % of merchandise imports) in Fuel in 1973 to that in 1974?
Offer a terse response. 0.63. What is the ratio of the Amount of imports(as % of merchandise imports) in Ores and metals in 1973 to that in 1975?
Offer a terse response. 0.43. What is the ratio of the Amount of imports(as % of merchandise imports) in Manufactures in 1973 to that in 1975?
Provide a short and direct response. 1.08. What is the ratio of the Amount of imports(as % of merchandise imports) in Fuel in 1973 to that in 1975?
Give a very brief answer. 0.69. What is the ratio of the Amount of imports(as % of merchandise imports) in Ores and metals in 1973 to that in 1976?
Ensure brevity in your answer.  0.39. What is the ratio of the Amount of imports(as % of merchandise imports) of Manufactures in 1973 to that in 1976?
Make the answer very short. 1.1. What is the ratio of the Amount of imports(as % of merchandise imports) of Fuel in 1973 to that in 1976?
Your answer should be very brief. 0.62. What is the ratio of the Amount of imports(as % of merchandise imports) in Ores and metals in 1973 to that in 1977?
Provide a short and direct response. 1.44. What is the ratio of the Amount of imports(as % of merchandise imports) of Fuel in 1973 to that in 1977?
Provide a short and direct response. 0.98. What is the ratio of the Amount of imports(as % of merchandise imports) of Ores and metals in 1973 to that in 1978?
Ensure brevity in your answer.  1.22. What is the ratio of the Amount of imports(as % of merchandise imports) in Manufactures in 1973 to that in 1978?
Make the answer very short. 1.01. What is the ratio of the Amount of imports(as % of merchandise imports) of Fuel in 1973 to that in 1978?
Keep it short and to the point. 0.64. What is the ratio of the Amount of imports(as % of merchandise imports) in Ores and metals in 1974 to that in 1975?
Provide a short and direct response. 0.51. What is the ratio of the Amount of imports(as % of merchandise imports) of Manufactures in 1974 to that in 1975?
Give a very brief answer. 1.06. What is the ratio of the Amount of imports(as % of merchandise imports) in Fuel in 1974 to that in 1975?
Ensure brevity in your answer.  1.09. What is the ratio of the Amount of imports(as % of merchandise imports) of Ores and metals in 1974 to that in 1976?
Your answer should be very brief. 0.46. What is the ratio of the Amount of imports(as % of merchandise imports) of Manufactures in 1974 to that in 1976?
Keep it short and to the point. 1.09. What is the ratio of the Amount of imports(as % of merchandise imports) in Fuel in 1974 to that in 1976?
Your response must be concise. 0.98. What is the ratio of the Amount of imports(as % of merchandise imports) of Ores and metals in 1974 to that in 1977?
Provide a succinct answer. 1.71. What is the ratio of the Amount of imports(as % of merchandise imports) in Fuel in 1974 to that in 1977?
Your response must be concise. 1.54. What is the ratio of the Amount of imports(as % of merchandise imports) in Ores and metals in 1974 to that in 1978?
Offer a terse response. 1.45. What is the ratio of the Amount of imports(as % of merchandise imports) of Manufactures in 1974 to that in 1978?
Provide a short and direct response. 1. What is the ratio of the Amount of imports(as % of merchandise imports) in Fuel in 1974 to that in 1978?
Provide a short and direct response. 1.01. What is the ratio of the Amount of imports(as % of merchandise imports) in Ores and metals in 1975 to that in 1976?
Your answer should be compact. 0.91. What is the ratio of the Amount of imports(as % of merchandise imports) in Manufactures in 1975 to that in 1976?
Provide a short and direct response. 1.02. What is the ratio of the Amount of imports(as % of merchandise imports) in Fuel in 1975 to that in 1976?
Provide a short and direct response. 0.9. What is the ratio of the Amount of imports(as % of merchandise imports) in Ores and metals in 1975 to that in 1977?
Offer a very short reply. 3.36. What is the ratio of the Amount of imports(as % of merchandise imports) of Manufactures in 1975 to that in 1977?
Offer a terse response. 0.94. What is the ratio of the Amount of imports(as % of merchandise imports) of Fuel in 1975 to that in 1977?
Offer a terse response. 1.41. What is the ratio of the Amount of imports(as % of merchandise imports) of Ores and metals in 1975 to that in 1978?
Your response must be concise. 2.83. What is the ratio of the Amount of imports(as % of merchandise imports) of Manufactures in 1975 to that in 1978?
Offer a terse response. 0.94. What is the ratio of the Amount of imports(as % of merchandise imports) of Fuel in 1975 to that in 1978?
Give a very brief answer. 0.93. What is the ratio of the Amount of imports(as % of merchandise imports) in Ores and metals in 1976 to that in 1977?
Offer a terse response. 3.7. What is the ratio of the Amount of imports(as % of merchandise imports) in Manufactures in 1976 to that in 1977?
Ensure brevity in your answer.  0.92. What is the ratio of the Amount of imports(as % of merchandise imports) in Fuel in 1976 to that in 1977?
Ensure brevity in your answer.  1.57. What is the ratio of the Amount of imports(as % of merchandise imports) of Ores and metals in 1976 to that in 1978?
Offer a very short reply. 3.13. What is the ratio of the Amount of imports(as % of merchandise imports) in Manufactures in 1976 to that in 1978?
Offer a very short reply. 0.92. What is the ratio of the Amount of imports(as % of merchandise imports) in Fuel in 1976 to that in 1978?
Your answer should be very brief. 1.03. What is the ratio of the Amount of imports(as % of merchandise imports) of Ores and metals in 1977 to that in 1978?
Offer a terse response. 0.84. What is the ratio of the Amount of imports(as % of merchandise imports) of Manufactures in 1977 to that in 1978?
Your answer should be compact. 1. What is the ratio of the Amount of imports(as % of merchandise imports) in Fuel in 1977 to that in 1978?
Your response must be concise. 0.66. What is the difference between the highest and the second highest Amount of imports(as % of merchandise imports) in Ores and metals?
Keep it short and to the point. 0.78. What is the difference between the highest and the second highest Amount of imports(as % of merchandise imports) in Manufactures?
Your answer should be compact. 0.85. What is the difference between the highest and the second highest Amount of imports(as % of merchandise imports) in Fuel?
Give a very brief answer. 0.13. What is the difference between the highest and the lowest Amount of imports(as % of merchandise imports) in Ores and metals?
Offer a terse response. 1.83. What is the difference between the highest and the lowest Amount of imports(as % of merchandise imports) of Manufactures?
Keep it short and to the point. 18.04. What is the difference between the highest and the lowest Amount of imports(as % of merchandise imports) in Fuel?
Offer a very short reply. 2.6. 